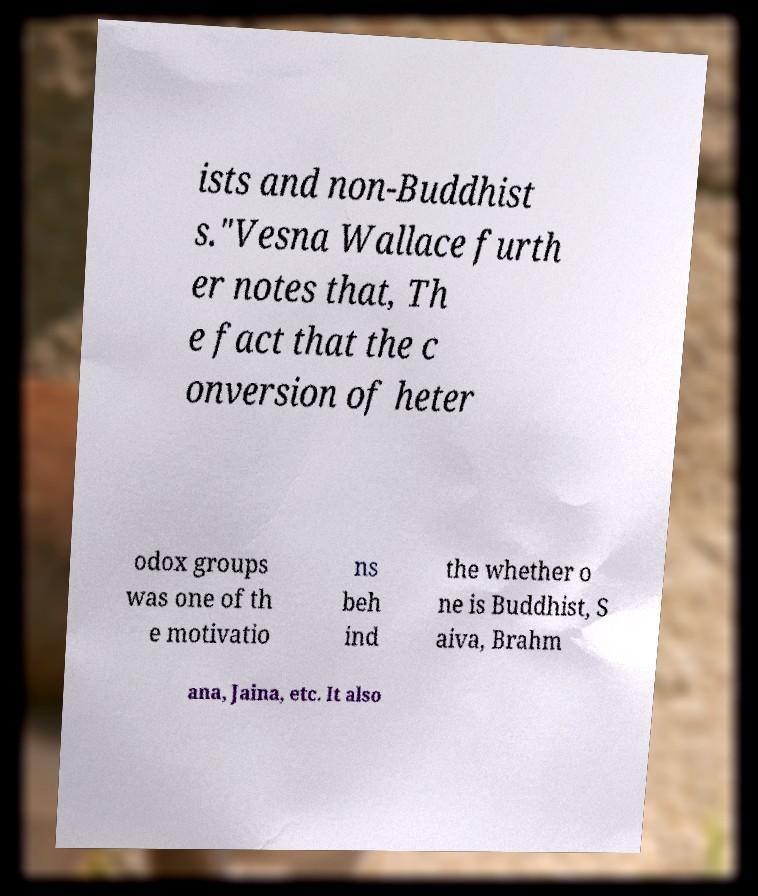I need the written content from this picture converted into text. Can you do that? ists and non-Buddhist s."Vesna Wallace furth er notes that, Th e fact that the c onversion of heter odox groups was one of th e motivatio ns beh ind the whether o ne is Buddhist, S aiva, Brahm ana, Jaina, etc. It also 